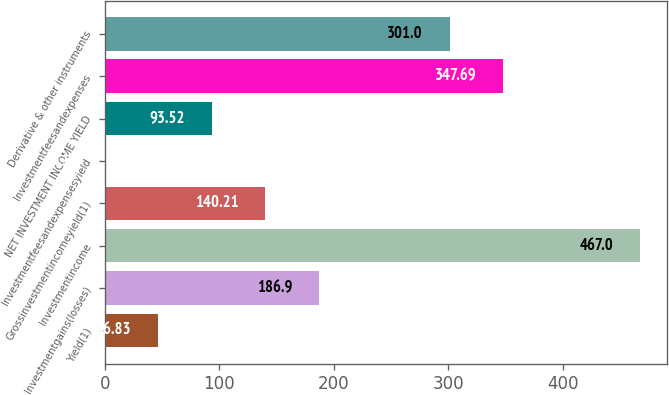Convert chart. <chart><loc_0><loc_0><loc_500><loc_500><bar_chart><fcel>Yield(1)<fcel>Investmentgains(losses)<fcel>Investmentincome<fcel>Grossinvestmentincomeyield(1)<fcel>Investmentfeesandexpensesyield<fcel>NET INVESTMENT INCOME YIELD<fcel>Investmentfeesandexpenses<fcel>Derivative & other instruments<nl><fcel>46.83<fcel>186.9<fcel>467<fcel>140.21<fcel>0.14<fcel>93.52<fcel>347.69<fcel>301<nl></chart> 